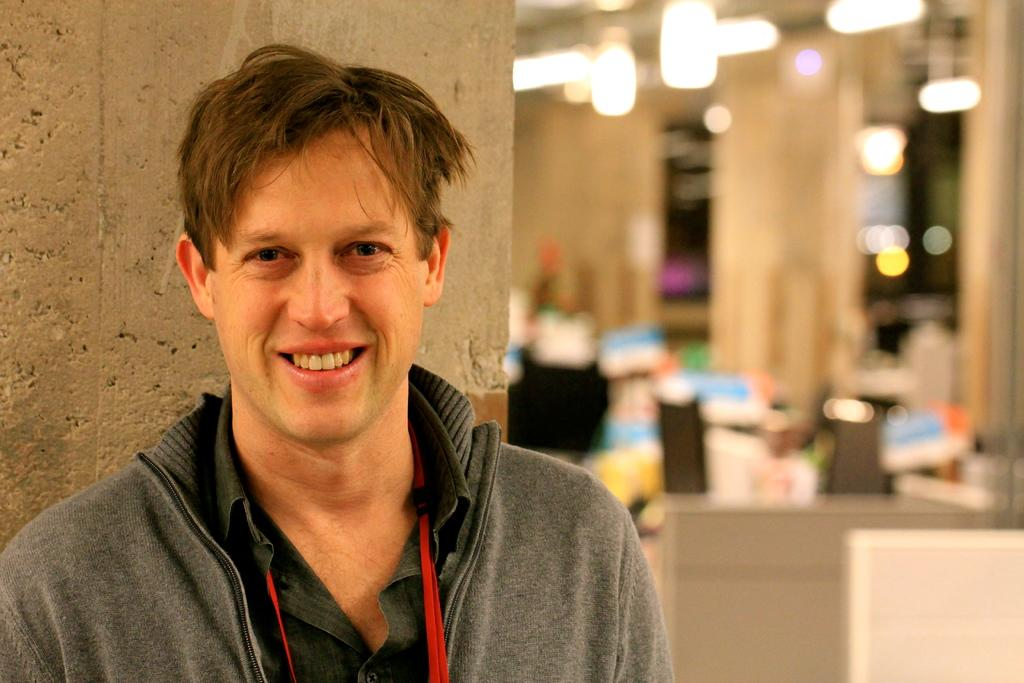Who is present in the image? There is a man in the image. What expression does the man have? The man is smiling. What can be seen in the background of the image? There is a wall in the image, and the background is blurred. What can be seen illuminated in the image? There are lights visible in the image. What type of cream is being used in the bath in the image? There is no bath or cream present in the image; it features a man smiling with a blurred background and visible lights. What type of celery is being served on the plate in the image? There is no plate or celery present in the image; it only features a man, a wall, and lights. 